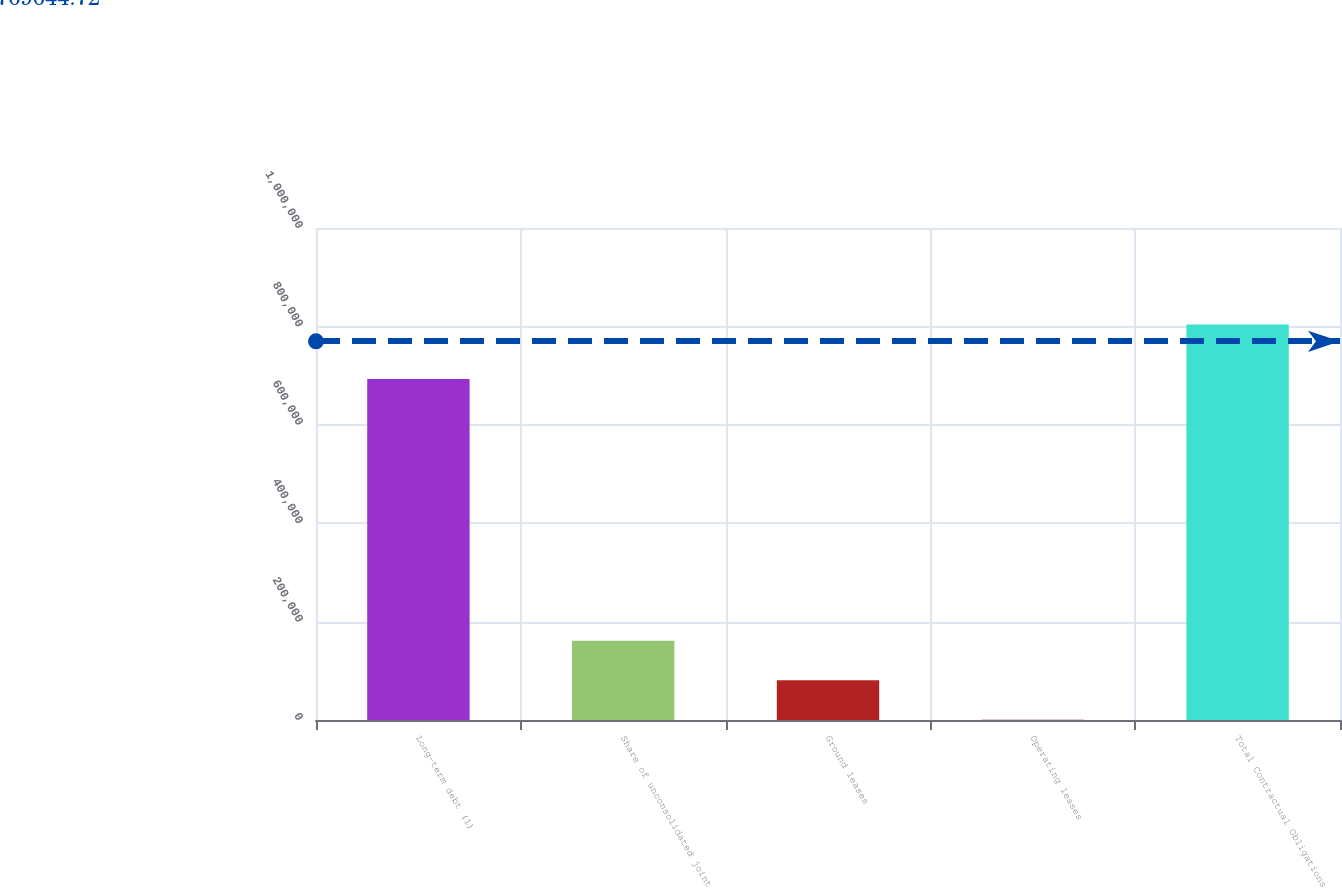<chart> <loc_0><loc_0><loc_500><loc_500><bar_chart><fcel>Long-term debt (1)<fcel>Share of unconsolidated joint<fcel>Ground leases<fcel>Operating leases<fcel>Total Contractual Obligations<nl><fcel>692959<fcel>161290<fcel>80994.4<fcel>699<fcel>803653<nl></chart> 